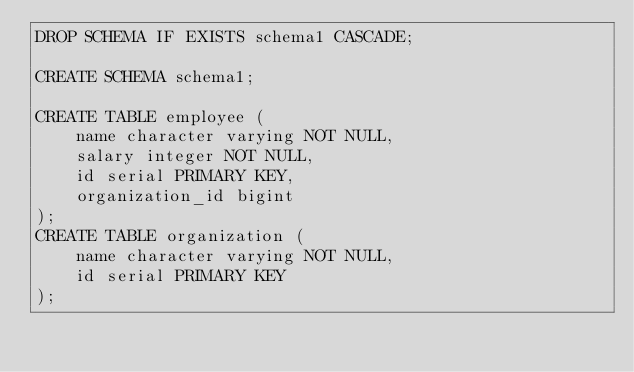<code> <loc_0><loc_0><loc_500><loc_500><_SQL_>DROP SCHEMA IF EXISTS schema1 CASCADE;

CREATE SCHEMA schema1;

CREATE TABLE employee (
    name character varying NOT NULL,
    salary integer NOT NULL,
    id serial PRIMARY KEY,
    organization_id bigint
);
CREATE TABLE organization (
    name character varying NOT NULL,
    id serial PRIMARY KEY
);
</code> 